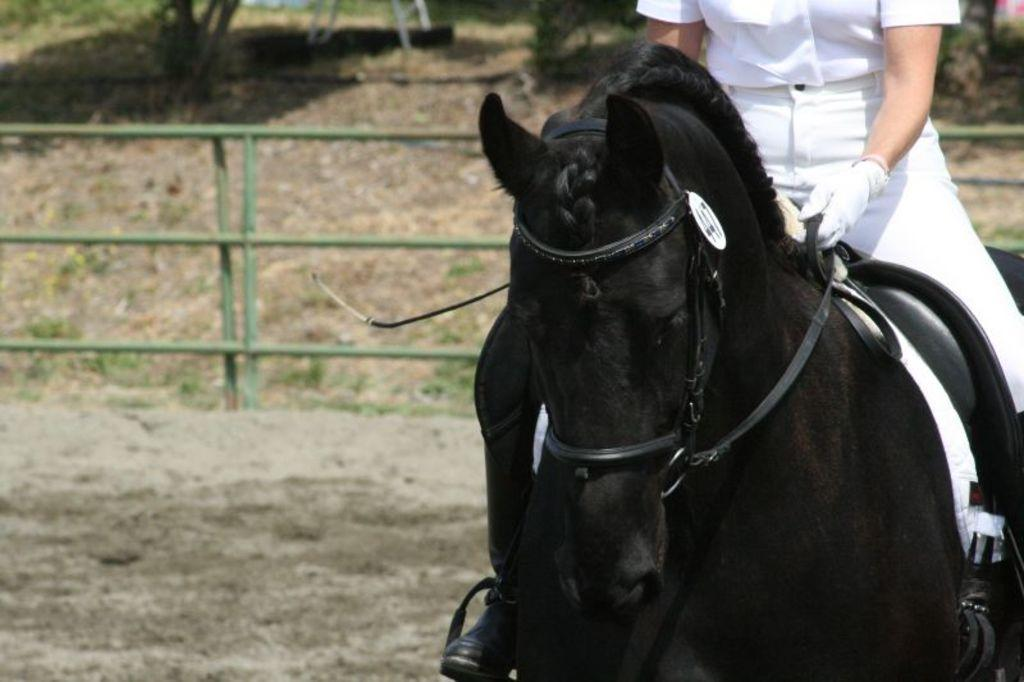What animal is present in the image? There is a horse in the image. What is the person on the horse doing? The person is sitting on the horse. What type of structure can be seen in the image? There is fencing visible in the image. How would you describe the background of the image? The background of the image is blurred. What type of hammer can be seen in the hand of the person sitting on the horse? There is no hammer present in the image; the person is simply sitting on the horse. How does the taste of the horse compare to that of a carrot? The image does not provide any information about the taste of the horse or a carrot, as it is a visual representation. 